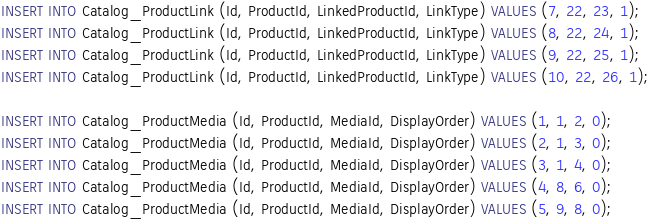<code> <loc_0><loc_0><loc_500><loc_500><_SQL_>INSERT INTO Catalog_ProductLink (Id, ProductId, LinkedProductId, LinkType) VALUES (7, 22, 23, 1);
INSERT INTO Catalog_ProductLink (Id, ProductId, LinkedProductId, LinkType) VALUES (8, 22, 24, 1);
INSERT INTO Catalog_ProductLink (Id, ProductId, LinkedProductId, LinkType) VALUES (9, 22, 25, 1);
INSERT INTO Catalog_ProductLink (Id, ProductId, LinkedProductId, LinkType) VALUES (10, 22, 26, 1);

INSERT INTO Catalog_ProductMedia (Id, ProductId, MediaId, DisplayOrder) VALUES (1, 1, 2, 0);
INSERT INTO Catalog_ProductMedia (Id, ProductId, MediaId, DisplayOrder) VALUES (2, 1, 3, 0);
INSERT INTO Catalog_ProductMedia (Id, ProductId, MediaId, DisplayOrder) VALUES (3, 1, 4, 0);
INSERT INTO Catalog_ProductMedia (Id, ProductId, MediaId, DisplayOrder) VALUES (4, 8, 6, 0);
INSERT INTO Catalog_ProductMedia (Id, ProductId, MediaId, DisplayOrder) VALUES (5, 9, 8, 0);</code> 